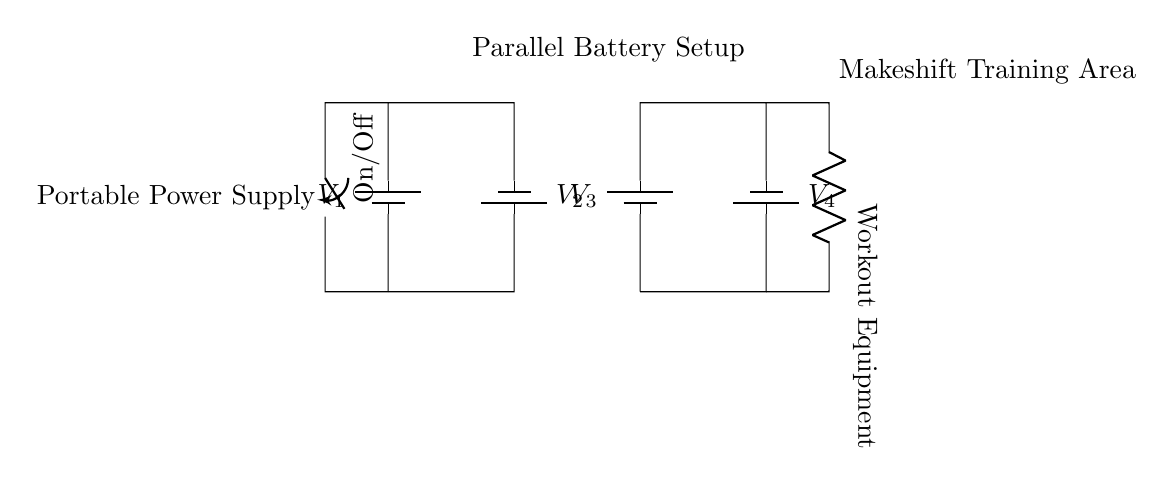What components are present in the circuit? The circuit includes two batteries, a switch, and a resistor. Each component contributes to the overall function of the portable power supply for the workout equipment.
Answer: batteries, switch, resistor What is the arrangement of the batteries? The batteries are arranged in parallel as indicated by their connections. Each battery connects directly to the power supply without series arrangement, allowing for increased current capacity while maintaining the same voltage.
Answer: parallel What is the purpose of the switch? The switch is utilized to control the flow of electricity to the workout equipment, allowing the user to easily turn the circuit on or off as needed.
Answer: control flow How many batteries are used in the setup? There are four batteries present in the circuit. Each battery is labeled and can be clearly counted from the diagram.
Answer: four What type of equipment is being powered by the circuit? The circuit is powering workout equipment, as indicated by the labeled resistor in the diagram that denotes the load in the circuit.
Answer: workout equipment If one battery has a voltage of 1.5V, what is the total voltage supplied to the equipment? In a parallel configuration, the voltage across each branch remains the same as that of an individual battery. Therefore, if each battery has a voltage of 1.5V, the total voltage supplied to the equipment remains 1.5V.
Answer: 1.5V Why is a parallel setup advantageous for portable equipment? A parallel setup allows for multiple batteries to combine their current capacity while maintaining the same voltage, ensuring consistent performance and prolonged usage for portable equipment in makeshift training areas.
Answer: efficiency 